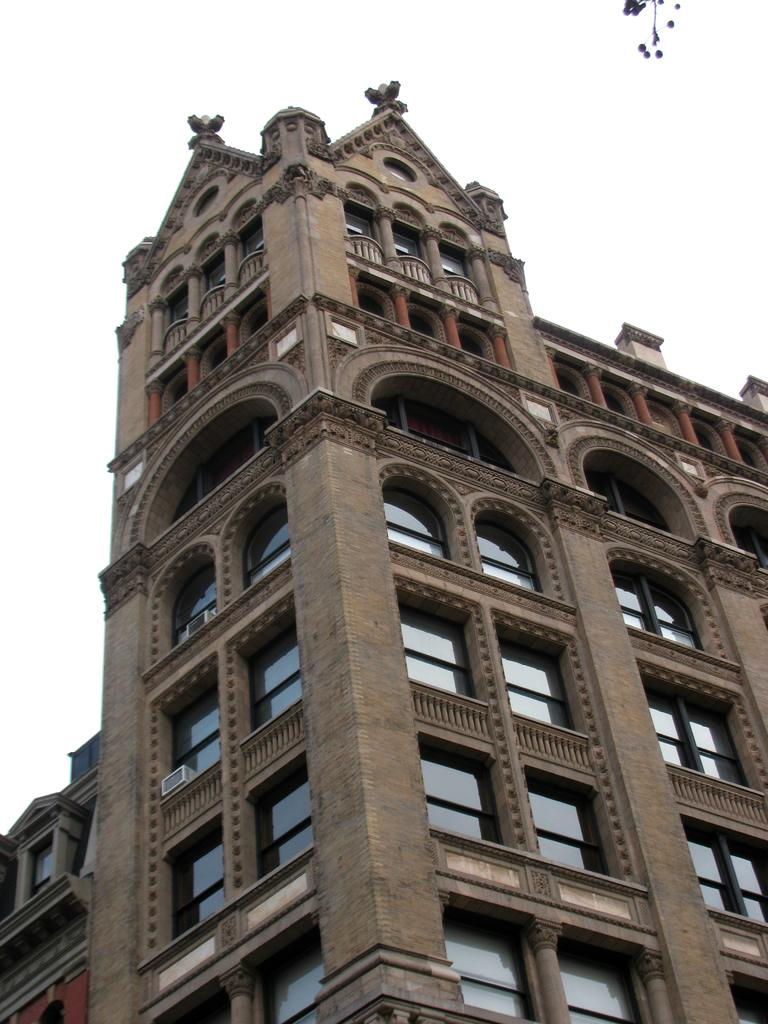What type of structure is visible in the image? There is a building in the image. What feature can be observed on the building? The building has glass windows. How would you describe the color of the sky in the image? The sky appears to be white in color. Where is the sister mentioned in the image? There is no mention of a sister in the image. Can you tell me the price of the coat seen in the image? There is no coat present in the image. 